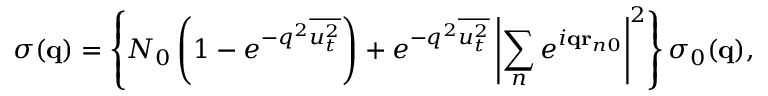Convert formula to latex. <formula><loc_0><loc_0><loc_500><loc_500>\sigma ( { q } ) = \left \{ N _ { 0 } \left ( 1 - e ^ { - q ^ { 2 } \overline { { { u _ { t } ^ { 2 } } } } } \right ) + e ^ { - q ^ { 2 } \overline { { { u _ { t } ^ { 2 } } } } } \left | \sum _ { n } e ^ { i { q r } _ { n 0 } } \right | ^ { 2 } \right \} \sigma _ { 0 } ( { q } ) ,</formula> 